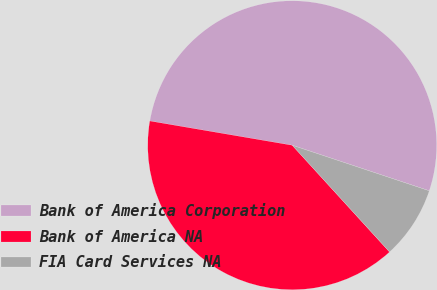Convert chart to OTSL. <chart><loc_0><loc_0><loc_500><loc_500><pie_chart><fcel>Bank of America Corporation<fcel>Bank of America NA<fcel>FIA Card Services NA<nl><fcel>52.42%<fcel>39.46%<fcel>8.12%<nl></chart> 